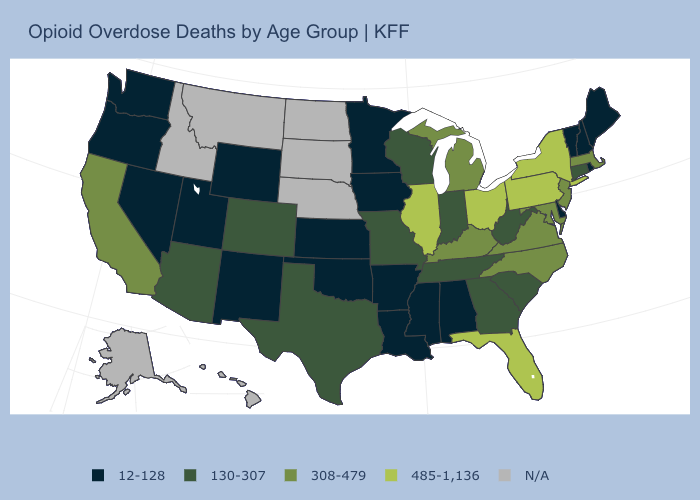What is the highest value in the USA?
Be succinct. 485-1,136. What is the value of Utah?
Quick response, please. 12-128. Which states have the highest value in the USA?
Be succinct. Florida, Illinois, New York, Ohio, Pennsylvania. Among the states that border Wyoming , which have the lowest value?
Write a very short answer. Utah. Which states hav the highest value in the South?
Be succinct. Florida. How many symbols are there in the legend?
Be succinct. 5. What is the lowest value in states that border Arizona?
Concise answer only. 12-128. What is the lowest value in the Northeast?
Keep it brief. 12-128. Does Florida have the highest value in the South?
Short answer required. Yes. What is the lowest value in states that border Rhode Island?
Quick response, please. 130-307. Name the states that have a value in the range N/A?
Keep it brief. Alaska, Hawaii, Idaho, Montana, Nebraska, North Dakota, South Dakota. Which states have the lowest value in the Northeast?
Write a very short answer. Maine, New Hampshire, Rhode Island, Vermont. Name the states that have a value in the range 308-479?
Write a very short answer. California, Kentucky, Maryland, Massachusetts, Michigan, New Jersey, North Carolina, Virginia. Name the states that have a value in the range 308-479?
Concise answer only. California, Kentucky, Maryland, Massachusetts, Michigan, New Jersey, North Carolina, Virginia. 